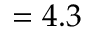Convert formula to latex. <formula><loc_0><loc_0><loc_500><loc_500>= 4 . 3</formula> 